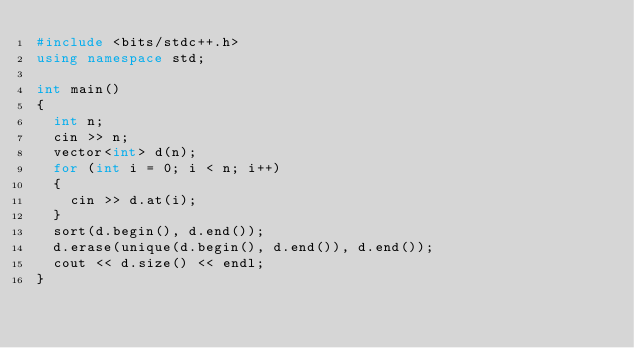<code> <loc_0><loc_0><loc_500><loc_500><_C++_>#include <bits/stdc++.h>
using namespace std;

int main()
{
  int n;
  cin >> n;
  vector<int> d(n);
  for (int i = 0; i < n; i++)
  {
    cin >> d.at(i);
  }
  sort(d.begin(), d.end());
  d.erase(unique(d.begin(), d.end()), d.end());
  cout << d.size() << endl;
}
</code> 